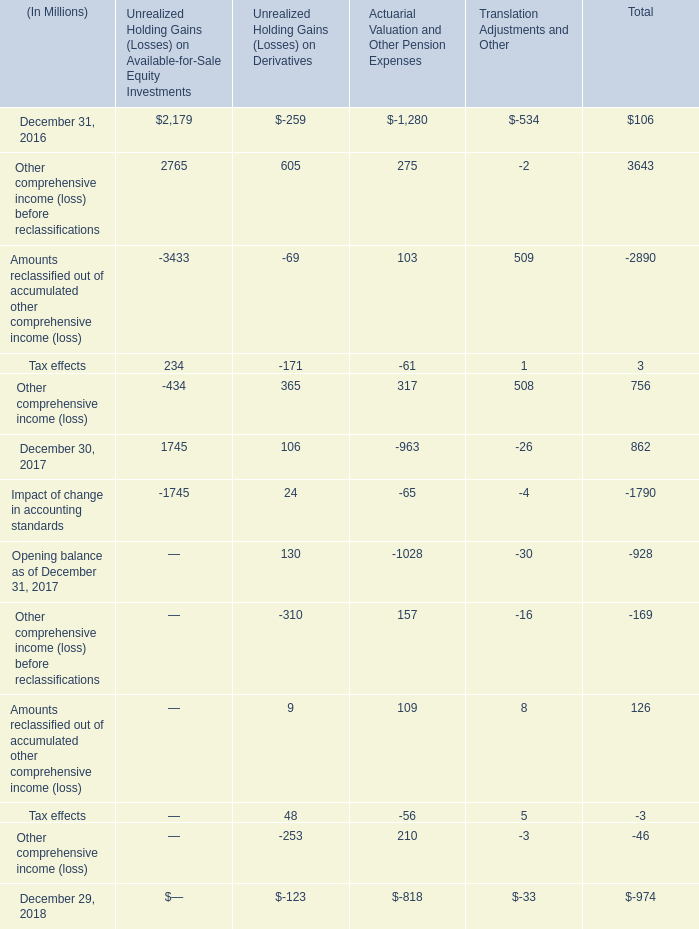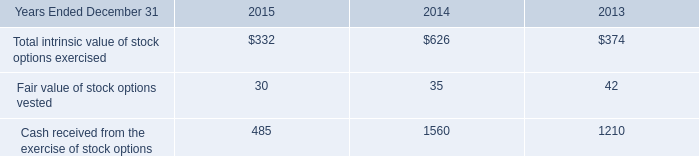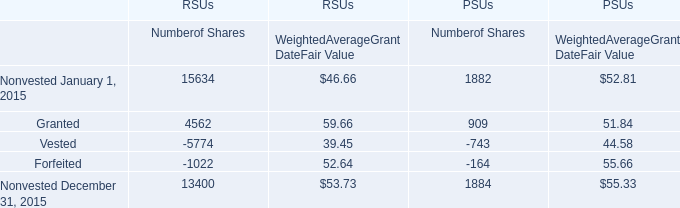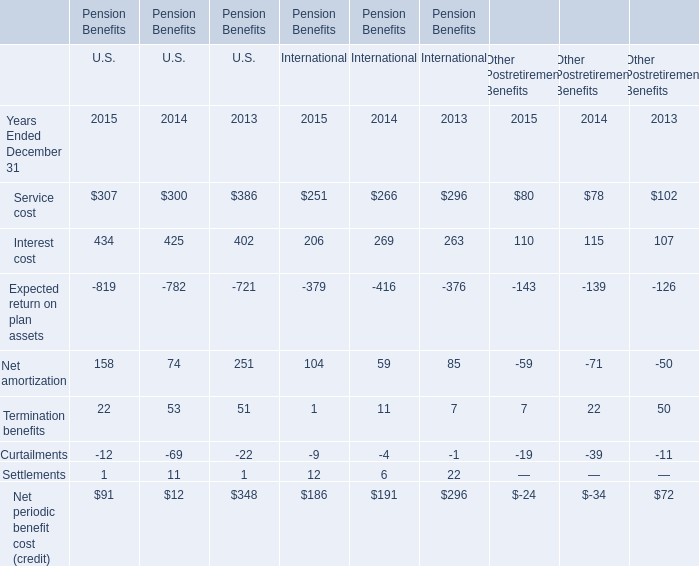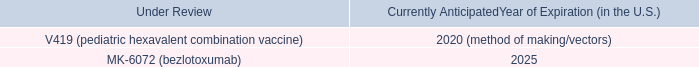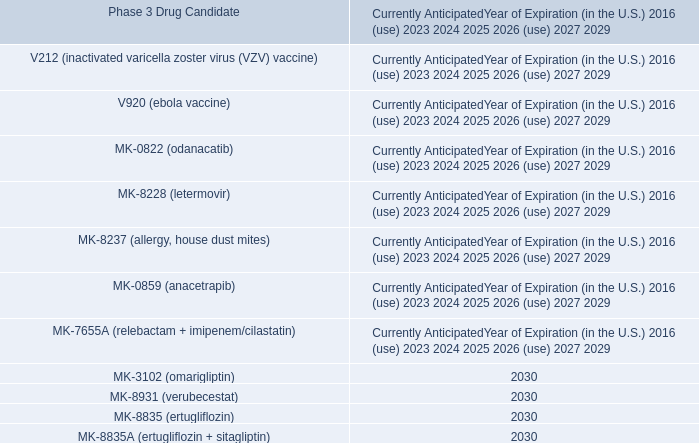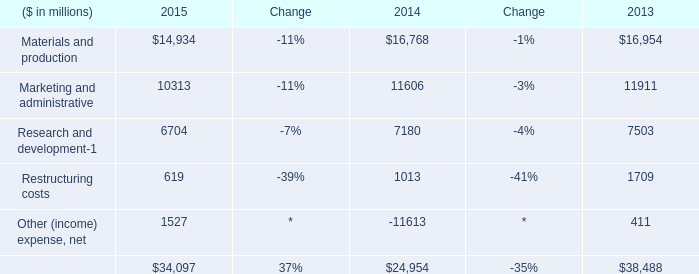What's the total value of all Numberof Shares that are smaller than 0 in 2015 for PSUs? 
Computations: (-743 - 164)
Answer: -907.0. 